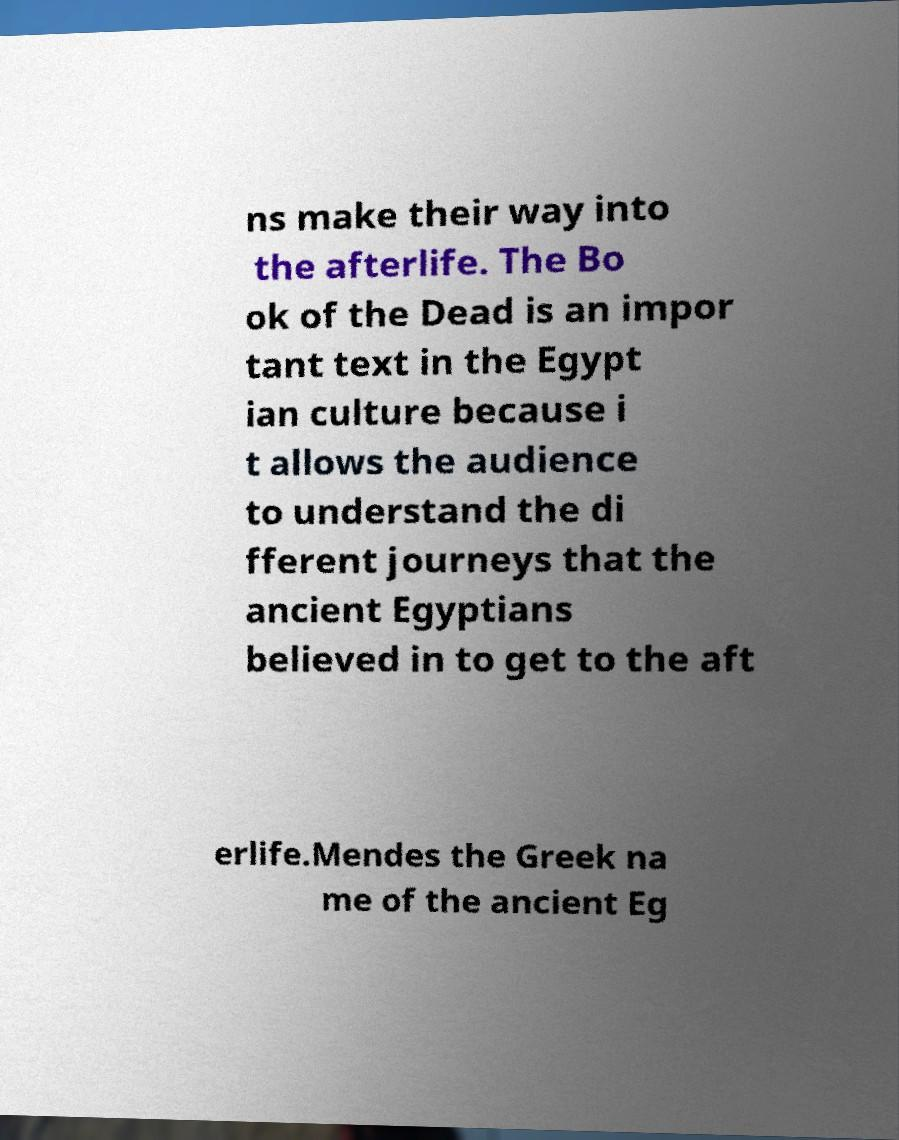There's text embedded in this image that I need extracted. Can you transcribe it verbatim? ns make their way into the afterlife. The Bo ok of the Dead is an impor tant text in the Egypt ian culture because i t allows the audience to understand the di fferent journeys that the ancient Egyptians believed in to get to the aft erlife.Mendes the Greek na me of the ancient Eg 